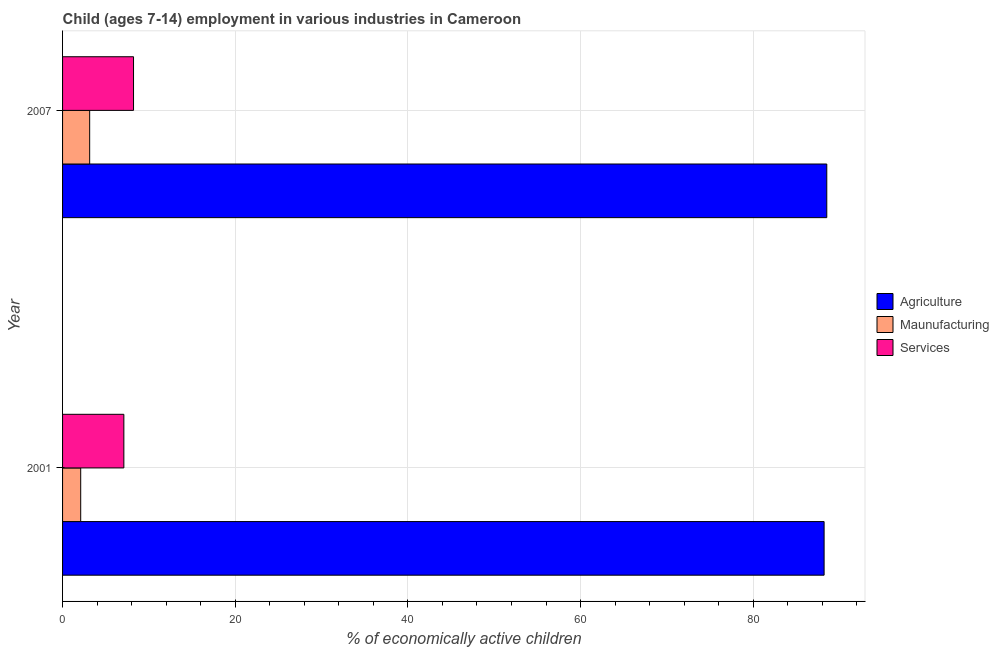Are the number of bars per tick equal to the number of legend labels?
Your response must be concise. Yes. What is the label of the 2nd group of bars from the top?
Give a very brief answer. 2001. In how many cases, is the number of bars for a given year not equal to the number of legend labels?
Your response must be concise. 0. What is the percentage of economically active children in services in 2007?
Give a very brief answer. 8.22. Across all years, what is the maximum percentage of economically active children in agriculture?
Your answer should be compact. 88.52. In which year was the percentage of economically active children in manufacturing minimum?
Provide a short and direct response. 2001. What is the total percentage of economically active children in services in the graph?
Provide a succinct answer. 15.32. What is the difference between the percentage of economically active children in agriculture in 2001 and that in 2007?
Offer a terse response. -0.31. What is the difference between the percentage of economically active children in manufacturing in 2007 and the percentage of economically active children in services in 2001?
Ensure brevity in your answer.  -3.96. What is the average percentage of economically active children in services per year?
Your response must be concise. 7.66. In the year 2007, what is the difference between the percentage of economically active children in agriculture and percentage of economically active children in manufacturing?
Ensure brevity in your answer.  85.38. Is the percentage of economically active children in manufacturing in 2001 less than that in 2007?
Ensure brevity in your answer.  Yes. Is the difference between the percentage of economically active children in agriculture in 2001 and 2007 greater than the difference between the percentage of economically active children in manufacturing in 2001 and 2007?
Offer a very short reply. Yes. In how many years, is the percentage of economically active children in services greater than the average percentage of economically active children in services taken over all years?
Give a very brief answer. 1. What does the 3rd bar from the top in 2001 represents?
Your answer should be compact. Agriculture. What does the 3rd bar from the bottom in 2001 represents?
Offer a very short reply. Services. Is it the case that in every year, the sum of the percentage of economically active children in agriculture and percentage of economically active children in manufacturing is greater than the percentage of economically active children in services?
Provide a succinct answer. Yes. How many bars are there?
Make the answer very short. 6. How many years are there in the graph?
Provide a succinct answer. 2. What is the difference between two consecutive major ticks on the X-axis?
Offer a very short reply. 20. Does the graph contain grids?
Make the answer very short. Yes. How are the legend labels stacked?
Your answer should be compact. Vertical. What is the title of the graph?
Ensure brevity in your answer.  Child (ages 7-14) employment in various industries in Cameroon. Does "Coal sources" appear as one of the legend labels in the graph?
Your answer should be very brief. No. What is the label or title of the X-axis?
Your answer should be very brief. % of economically active children. What is the % of economically active children in Agriculture in 2001?
Make the answer very short. 88.21. What is the % of economically active children in Maunufacturing in 2001?
Ensure brevity in your answer.  2.1. What is the % of economically active children of Services in 2001?
Ensure brevity in your answer.  7.1. What is the % of economically active children in Agriculture in 2007?
Ensure brevity in your answer.  88.52. What is the % of economically active children of Maunufacturing in 2007?
Provide a short and direct response. 3.14. What is the % of economically active children of Services in 2007?
Offer a terse response. 8.22. Across all years, what is the maximum % of economically active children in Agriculture?
Offer a terse response. 88.52. Across all years, what is the maximum % of economically active children in Maunufacturing?
Provide a succinct answer. 3.14. Across all years, what is the maximum % of economically active children of Services?
Keep it short and to the point. 8.22. Across all years, what is the minimum % of economically active children in Agriculture?
Ensure brevity in your answer.  88.21. Across all years, what is the minimum % of economically active children of Services?
Provide a succinct answer. 7.1. What is the total % of economically active children in Agriculture in the graph?
Your answer should be very brief. 176.73. What is the total % of economically active children of Maunufacturing in the graph?
Offer a very short reply. 5.24. What is the total % of economically active children of Services in the graph?
Provide a succinct answer. 15.32. What is the difference between the % of economically active children in Agriculture in 2001 and that in 2007?
Provide a succinct answer. -0.31. What is the difference between the % of economically active children in Maunufacturing in 2001 and that in 2007?
Offer a terse response. -1.04. What is the difference between the % of economically active children in Services in 2001 and that in 2007?
Your answer should be very brief. -1.12. What is the difference between the % of economically active children of Agriculture in 2001 and the % of economically active children of Maunufacturing in 2007?
Provide a short and direct response. 85.07. What is the difference between the % of economically active children of Agriculture in 2001 and the % of economically active children of Services in 2007?
Provide a succinct answer. 79.99. What is the difference between the % of economically active children of Maunufacturing in 2001 and the % of economically active children of Services in 2007?
Keep it short and to the point. -6.12. What is the average % of economically active children in Agriculture per year?
Your answer should be very brief. 88.36. What is the average % of economically active children of Maunufacturing per year?
Your answer should be very brief. 2.62. What is the average % of economically active children in Services per year?
Keep it short and to the point. 7.66. In the year 2001, what is the difference between the % of economically active children of Agriculture and % of economically active children of Maunufacturing?
Offer a terse response. 86.11. In the year 2001, what is the difference between the % of economically active children in Agriculture and % of economically active children in Services?
Your answer should be very brief. 81.11. In the year 2001, what is the difference between the % of economically active children in Maunufacturing and % of economically active children in Services?
Give a very brief answer. -5. In the year 2007, what is the difference between the % of economically active children of Agriculture and % of economically active children of Maunufacturing?
Give a very brief answer. 85.38. In the year 2007, what is the difference between the % of economically active children of Agriculture and % of economically active children of Services?
Offer a terse response. 80.3. In the year 2007, what is the difference between the % of economically active children of Maunufacturing and % of economically active children of Services?
Ensure brevity in your answer.  -5.08. What is the ratio of the % of economically active children in Maunufacturing in 2001 to that in 2007?
Provide a short and direct response. 0.67. What is the ratio of the % of economically active children of Services in 2001 to that in 2007?
Make the answer very short. 0.86. What is the difference between the highest and the second highest % of economically active children in Agriculture?
Ensure brevity in your answer.  0.31. What is the difference between the highest and the second highest % of economically active children in Services?
Provide a short and direct response. 1.12. What is the difference between the highest and the lowest % of economically active children of Agriculture?
Keep it short and to the point. 0.31. What is the difference between the highest and the lowest % of economically active children of Services?
Your answer should be very brief. 1.12. 